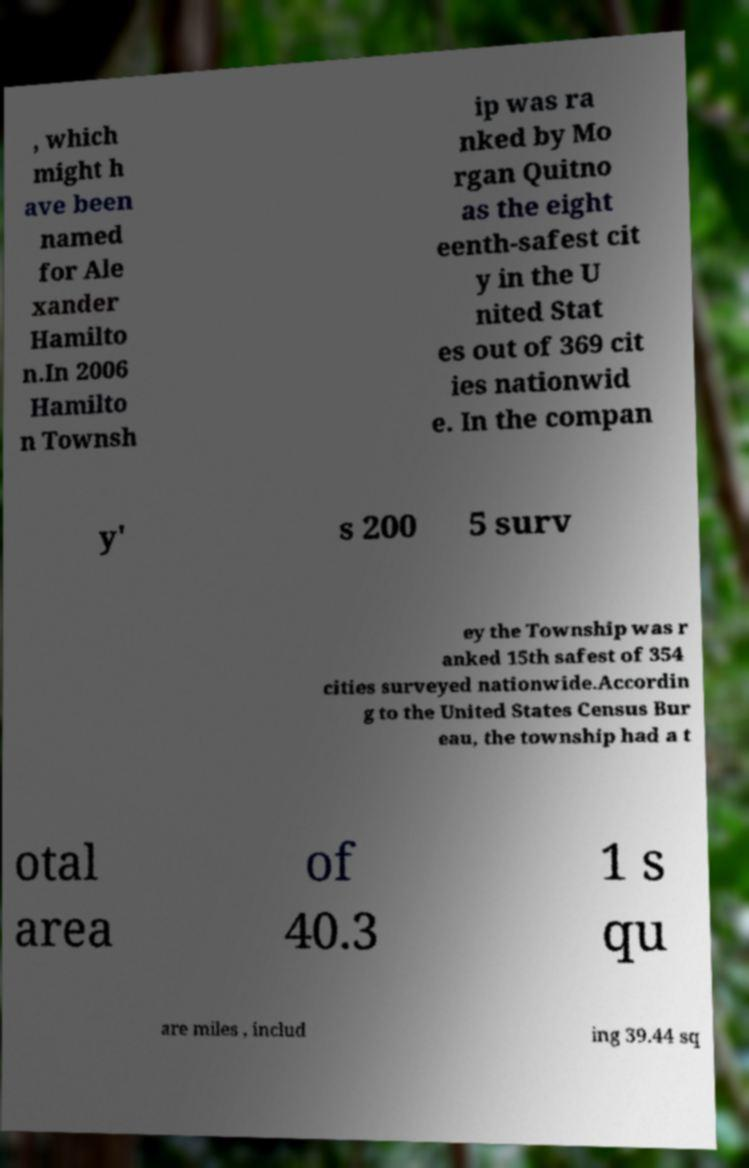Please read and relay the text visible in this image. What does it say? , which might h ave been named for Ale xander Hamilto n.In 2006 Hamilto n Townsh ip was ra nked by Mo rgan Quitno as the eight eenth-safest cit y in the U nited Stat es out of 369 cit ies nationwid e. In the compan y' s 200 5 surv ey the Township was r anked 15th safest of 354 cities surveyed nationwide.Accordin g to the United States Census Bur eau, the township had a t otal area of 40.3 1 s qu are miles , includ ing 39.44 sq 